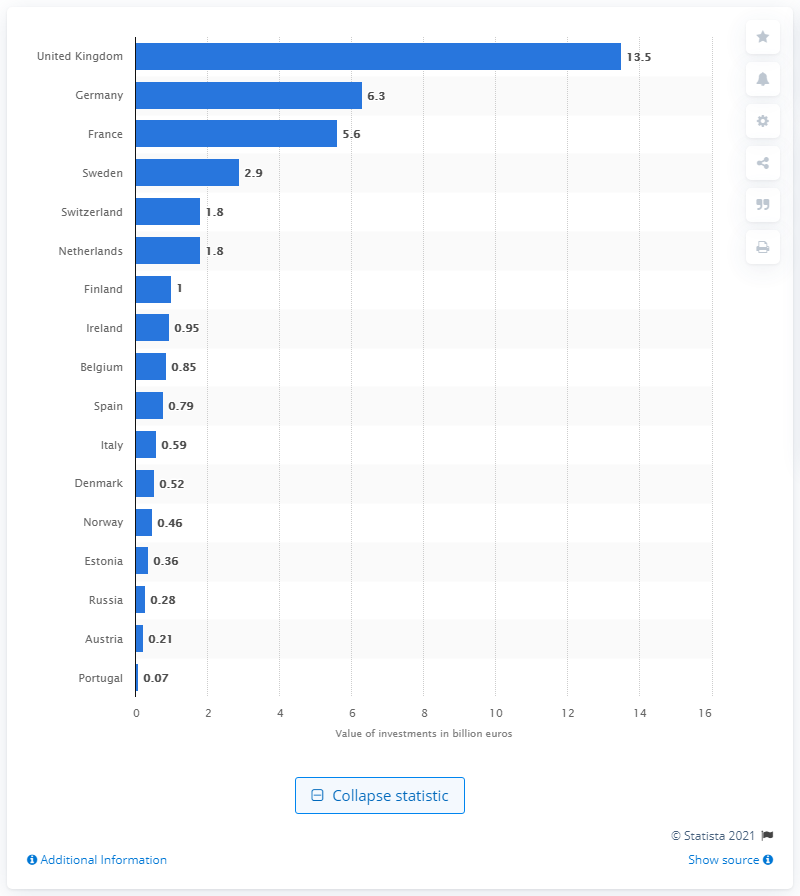List a handful of essential elements in this visual. The value of investments made by Germany was 6.3.. In 2020, the value of investments by venture capital firms in the United Kingdom totaled 13.5 billion dollars. 